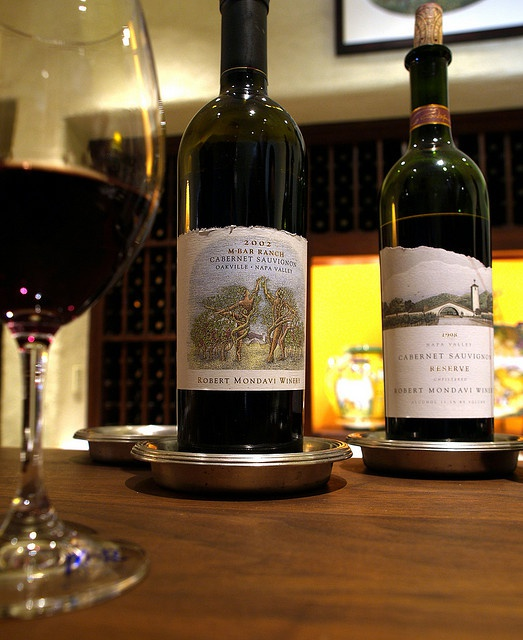Describe the objects in this image and their specific colors. I can see dining table in olive, maroon, brown, and black tones, wine glass in olive, black, tan, and maroon tones, bottle in olive, black, gray, and darkgray tones, bottle in olive, black, lightgray, gray, and darkgray tones, and bottle in olive, yellow, black, and khaki tones in this image. 